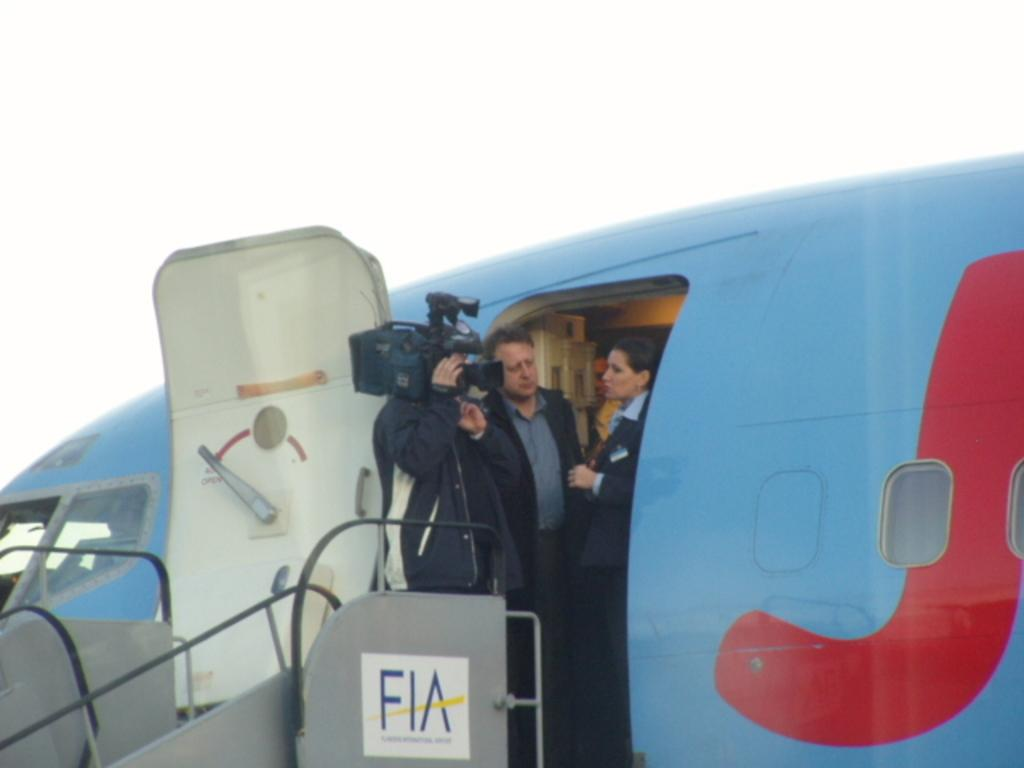<image>
Share a concise interpretation of the image provided. A man with a camera stands atop of a set of FIA stairs that connect to an airplane. 